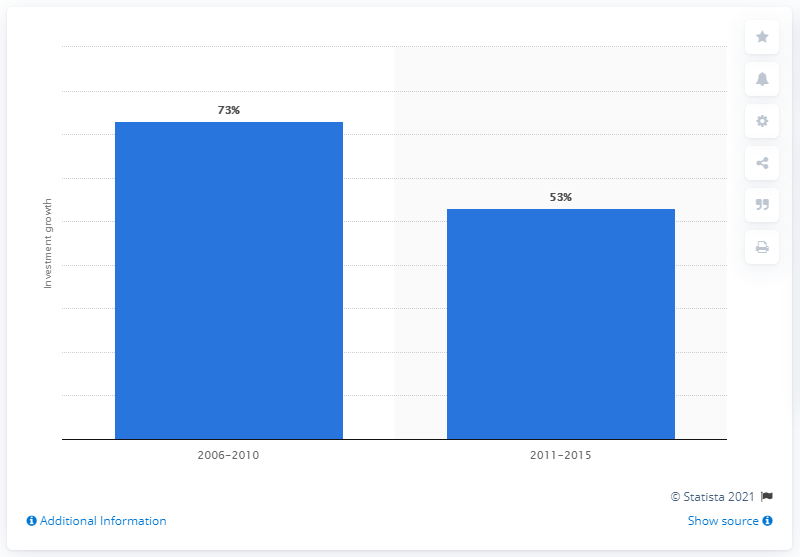Give some essential details in this illustration. Personalized medicine investment grew by 73% between 2006 and 2010. 